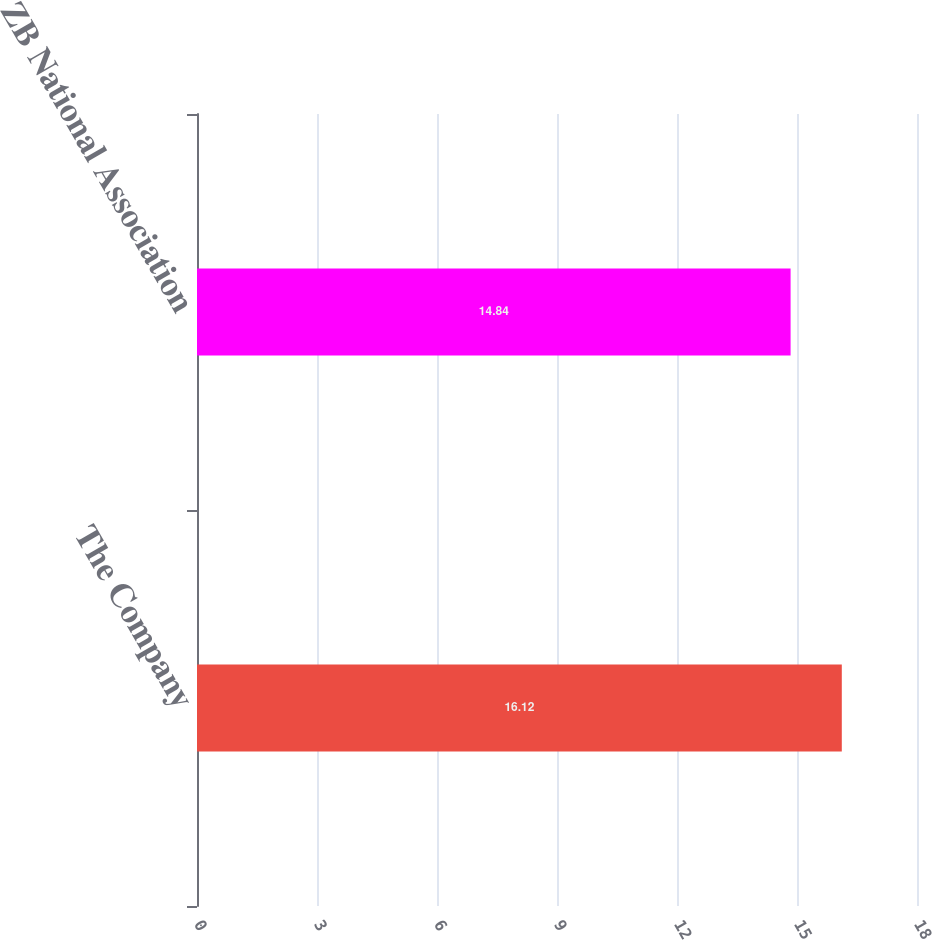Convert chart to OTSL. <chart><loc_0><loc_0><loc_500><loc_500><bar_chart><fcel>The Company<fcel>ZB National Association<nl><fcel>16.12<fcel>14.84<nl></chart> 